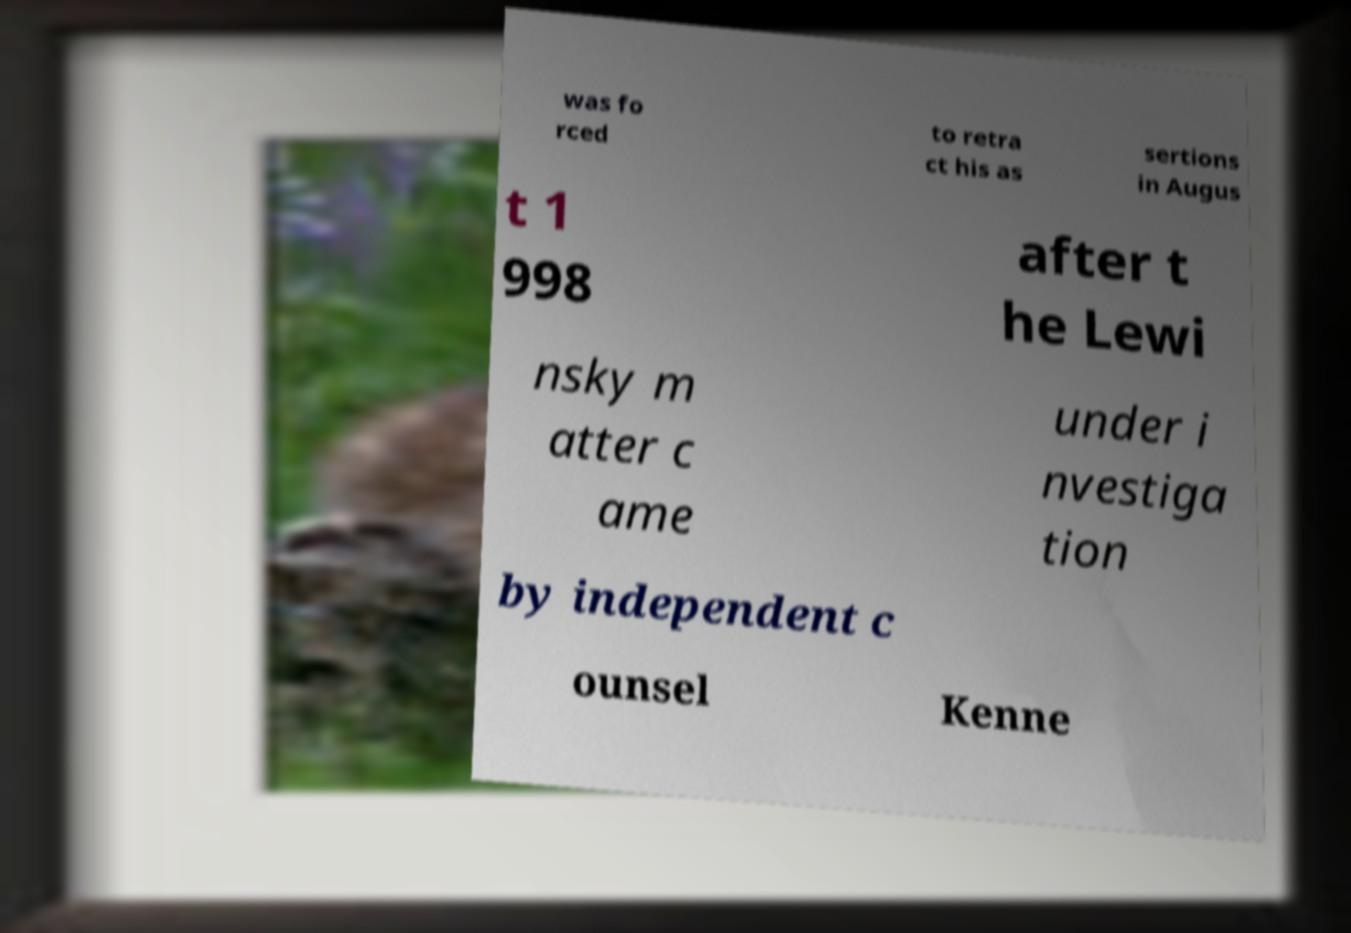Please identify and transcribe the text found in this image. was fo rced to retra ct his as sertions in Augus t 1 998 after t he Lewi nsky m atter c ame under i nvestiga tion by independent c ounsel Kenne 